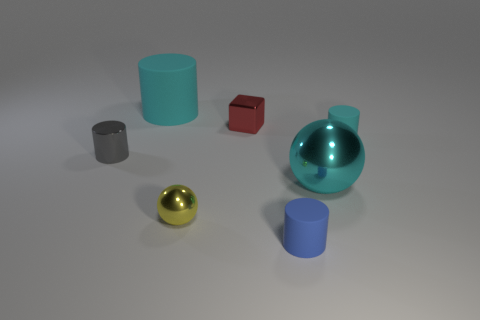Subtract all blue cubes. Subtract all red cylinders. How many cubes are left? 1 Add 2 large blue matte objects. How many objects exist? 9 Subtract all cubes. How many objects are left? 6 Add 5 green cubes. How many green cubes exist? 5 Subtract 1 red blocks. How many objects are left? 6 Subtract all tiny purple rubber cylinders. Subtract all gray objects. How many objects are left? 6 Add 2 tiny blocks. How many tiny blocks are left? 3 